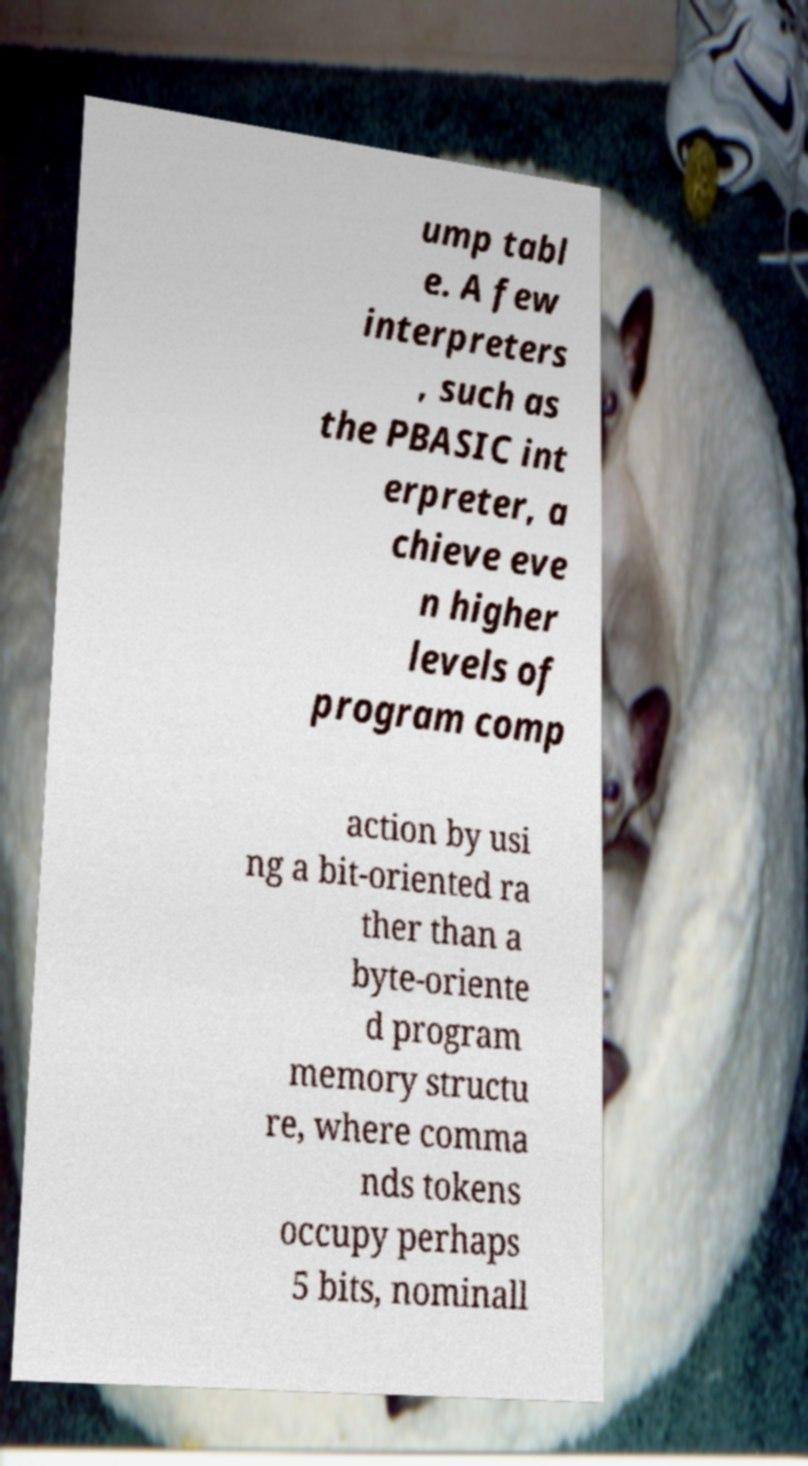Can you read and provide the text displayed in the image?This photo seems to have some interesting text. Can you extract and type it out for me? ump tabl e. A few interpreters , such as the PBASIC int erpreter, a chieve eve n higher levels of program comp action by usi ng a bit-oriented ra ther than a byte-oriente d program memory structu re, where comma nds tokens occupy perhaps 5 bits, nominall 